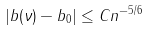Convert formula to latex. <formula><loc_0><loc_0><loc_500><loc_500>| b ( \nu ) - b _ { 0 } | \leq C n ^ { - 5 / 6 }</formula> 